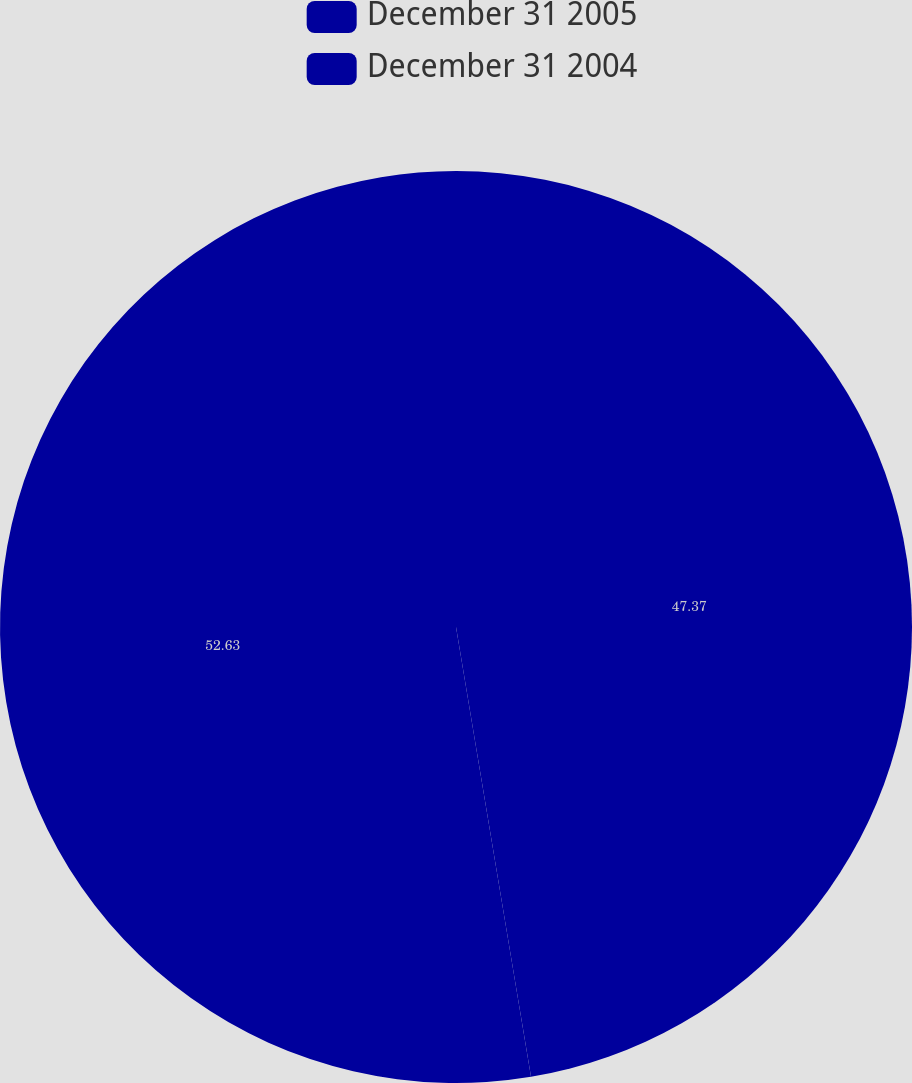<chart> <loc_0><loc_0><loc_500><loc_500><pie_chart><fcel>December 31 2005<fcel>December 31 2004<nl><fcel>47.37%<fcel>52.63%<nl></chart> 